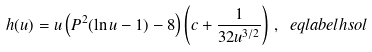<formula> <loc_0><loc_0><loc_500><loc_500>h ( u ) = u \left ( P ^ { 2 } ( \ln u - 1 ) - 8 \right ) \left ( c + \frac { 1 } { 3 2 u ^ { 3 / 2 } } \right ) \, , \ e q l a b e l { h s o l }</formula> 